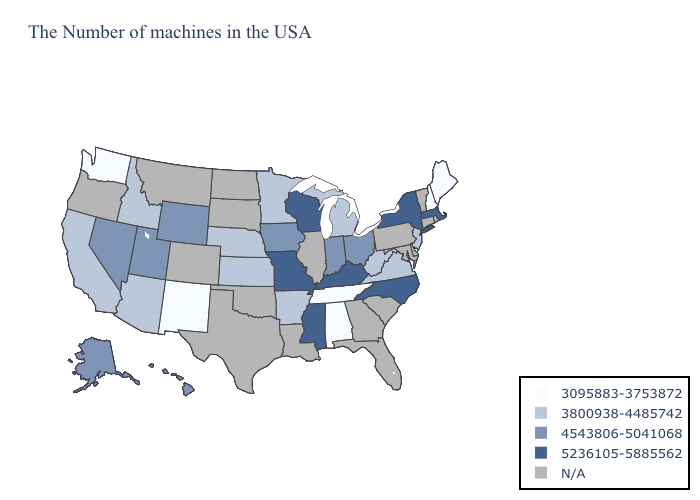What is the value of Minnesota?
Short answer required. 3800938-4485742. What is the lowest value in states that border Connecticut?
Write a very short answer. 5236105-5885562. Name the states that have a value in the range 3800938-4485742?
Answer briefly. New Jersey, Virginia, West Virginia, Michigan, Arkansas, Minnesota, Kansas, Nebraska, Arizona, Idaho, California. Name the states that have a value in the range 4543806-5041068?
Quick response, please. Ohio, Indiana, Iowa, Wyoming, Utah, Nevada, Alaska, Hawaii. Among the states that border New York , does New Jersey have the highest value?
Concise answer only. No. What is the highest value in states that border Montana?
Give a very brief answer. 4543806-5041068. Does the map have missing data?
Be succinct. Yes. Name the states that have a value in the range 4543806-5041068?
Be succinct. Ohio, Indiana, Iowa, Wyoming, Utah, Nevada, Alaska, Hawaii. Is the legend a continuous bar?
Keep it brief. No. Name the states that have a value in the range 3800938-4485742?
Give a very brief answer. New Jersey, Virginia, West Virginia, Michigan, Arkansas, Minnesota, Kansas, Nebraska, Arizona, Idaho, California. What is the lowest value in the South?
Write a very short answer. 3095883-3753872. What is the value of Mississippi?
Short answer required. 5236105-5885562. Does Missouri have the highest value in the USA?
Write a very short answer. Yes. Among the states that border Utah , does New Mexico have the lowest value?
Write a very short answer. Yes. What is the value of Illinois?
Give a very brief answer. N/A. 